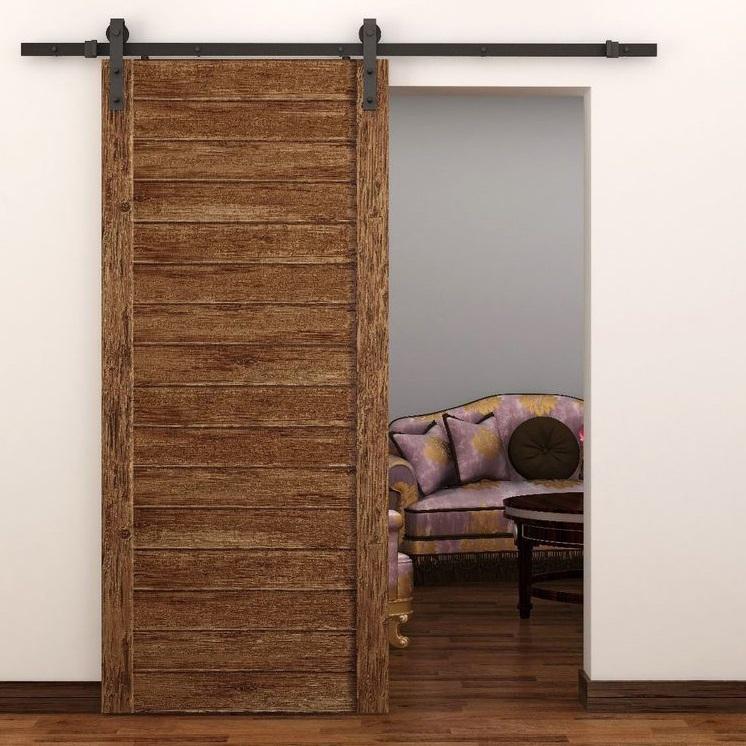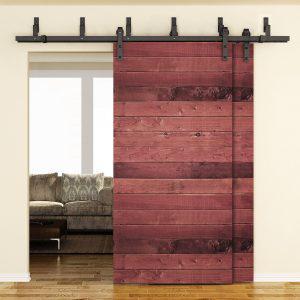The first image is the image on the left, the second image is the image on the right. For the images shown, is this caption "In one image, a wooden free-standing wardrobe has sliding doors, one of which is open." true? Answer yes or no. No. The first image is the image on the left, the second image is the image on the right. Examine the images to the left and right. Is the description "One image shows a sliding wood-grain door with a black horizontal band in the center." accurate? Answer yes or no. No. 